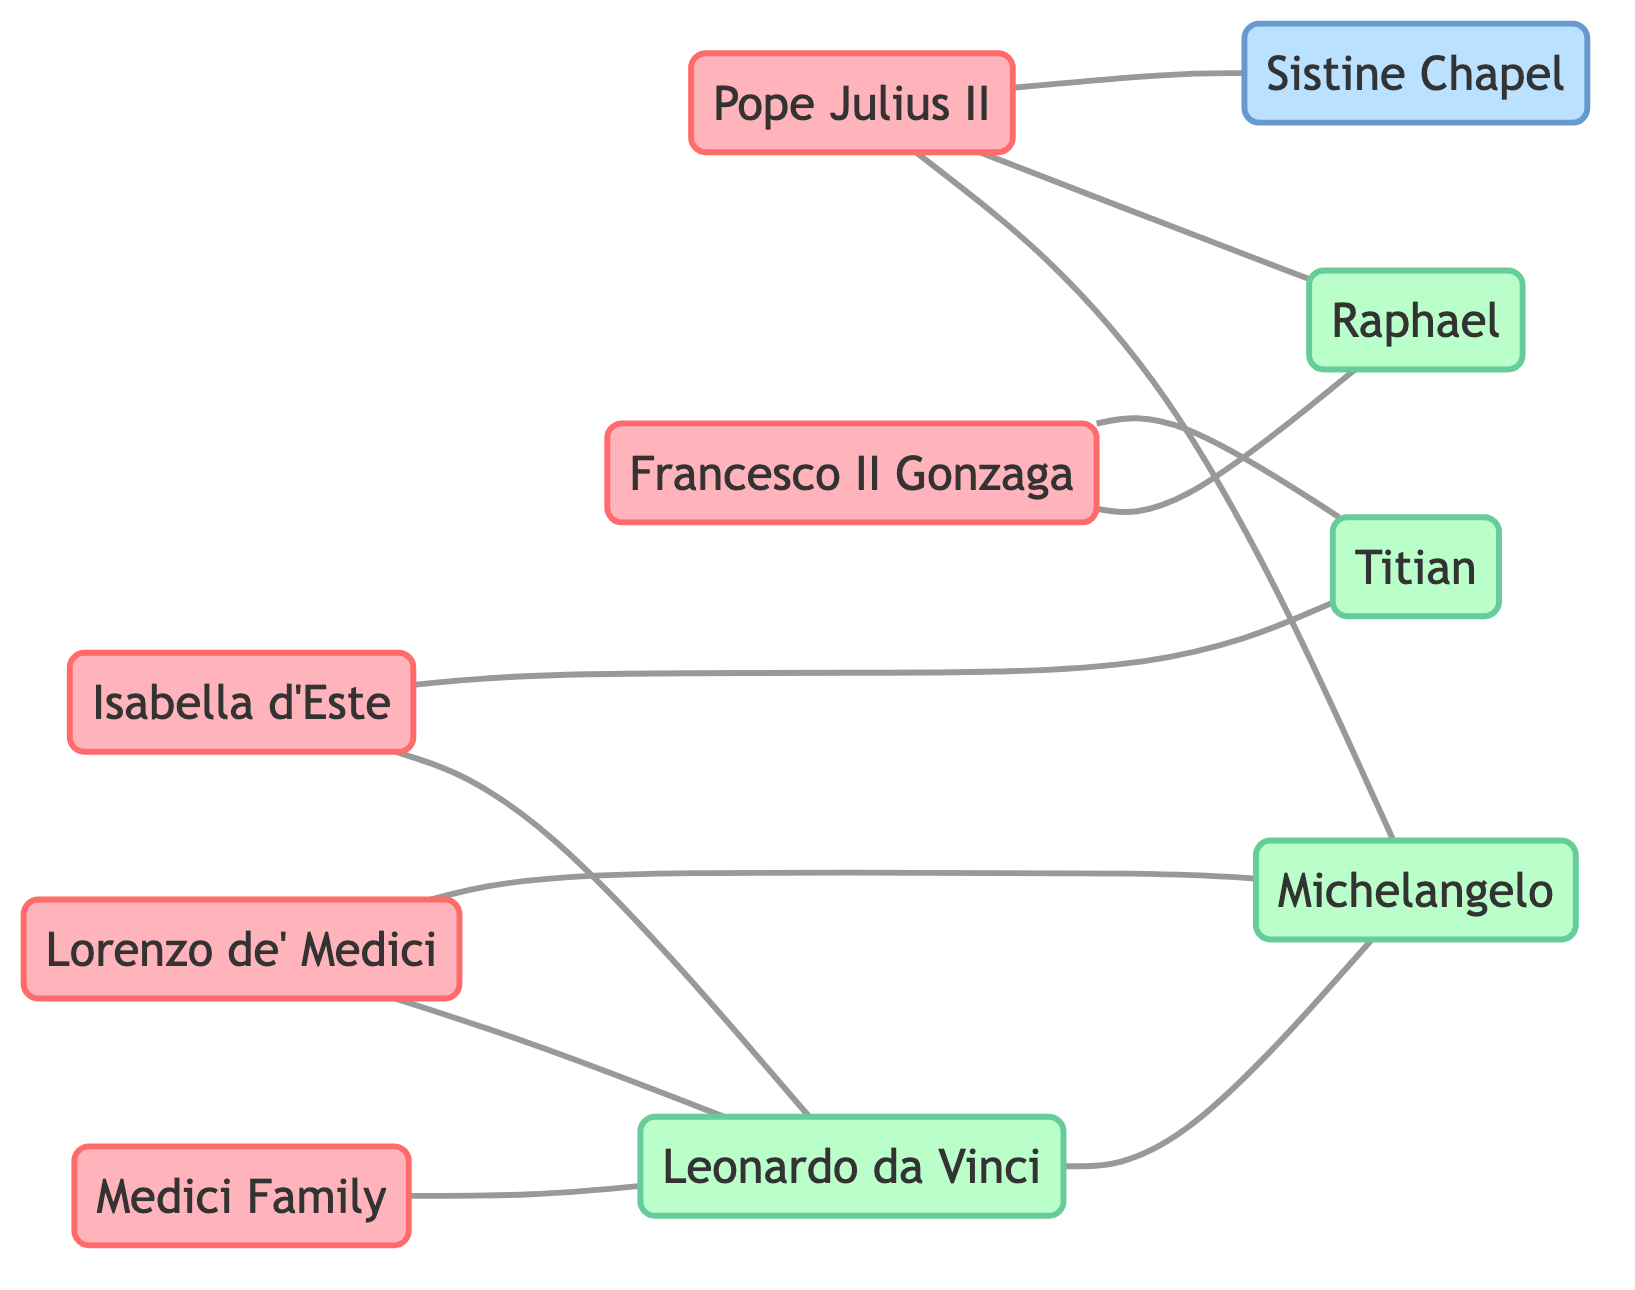What is the total number of nodes in the diagram? The diagram consists of ten nodes: Medici Family, Lorenzo de’ Medici, Pope Julius II, Isabella d’Este, Francesco II Gonzaga, Leonardo da Vinci, Michelangelo, Raphael, Titian, and Sistine Chapel. Therefore, the total number is 10.
Answer: 10 Who is connected to Isabella d’Este? Isabella d’Este is connected to two nodes: Leonardo da Vinci and Titian. By examining the edges from Isabella d’Este, we see these direct relationships.
Answer: Leonardo da Vinci, Titian Which artist is represented as being connected to the most patrons? By analyzing the connections, Leonardo da Vinci appears connected to four patrons in total: Medici Family, Lorenzo de’ Medici, Isabella d’Este, and Michelangelo (as an artist). Therefore, he has the highest number of patron connections.
Answer: Leonardo da Vinci What is the relationship between Pope Julius II and the Sistine Chapel? The edge directly connects Pope Julius II to the Sistine Chapel, indicating that he was one of the key patrons behind its commissioning. The relationship here is direct patronage evidenced in the diagram.
Answer: Patronage How many edges connect to Michelangelo and which nodes are they? Michelangelo has three edges connected to him: one from Lorenzo de’ Medici, one from Pope Julius II, and one from Leonardo da Vinci. Therefore, he is related to these three other nodes.
Answer: 3 (Lorenzo de’ Medici, Pope Julius II, Leonardo da Vinci) Which two artists share a connection with Pope Julius II? Looking at the diagram, Pope Julius II is connected to Raphael and Michelangelo, indicating that these two artists have a relationship through patronage with him.
Answer: Raphael, Michelangelo What type of artwork is associated with Pope Julius II? The edge connecting Pope Julius II and the Sistine Chapel highlights that this artwork is associated with him as a major patron in the diagram. This indicates direct involvement in its commissioning.
Answer: Sistine Chapel Who are the two patrons connected to Titian? Titian is connected to two patrons: Isabella d’Este and Francesco II Gonzaga, as indicated by the edges leading from these nodes to Titian.
Answer: Isabella d’Este, Francesco II Gonzaga 